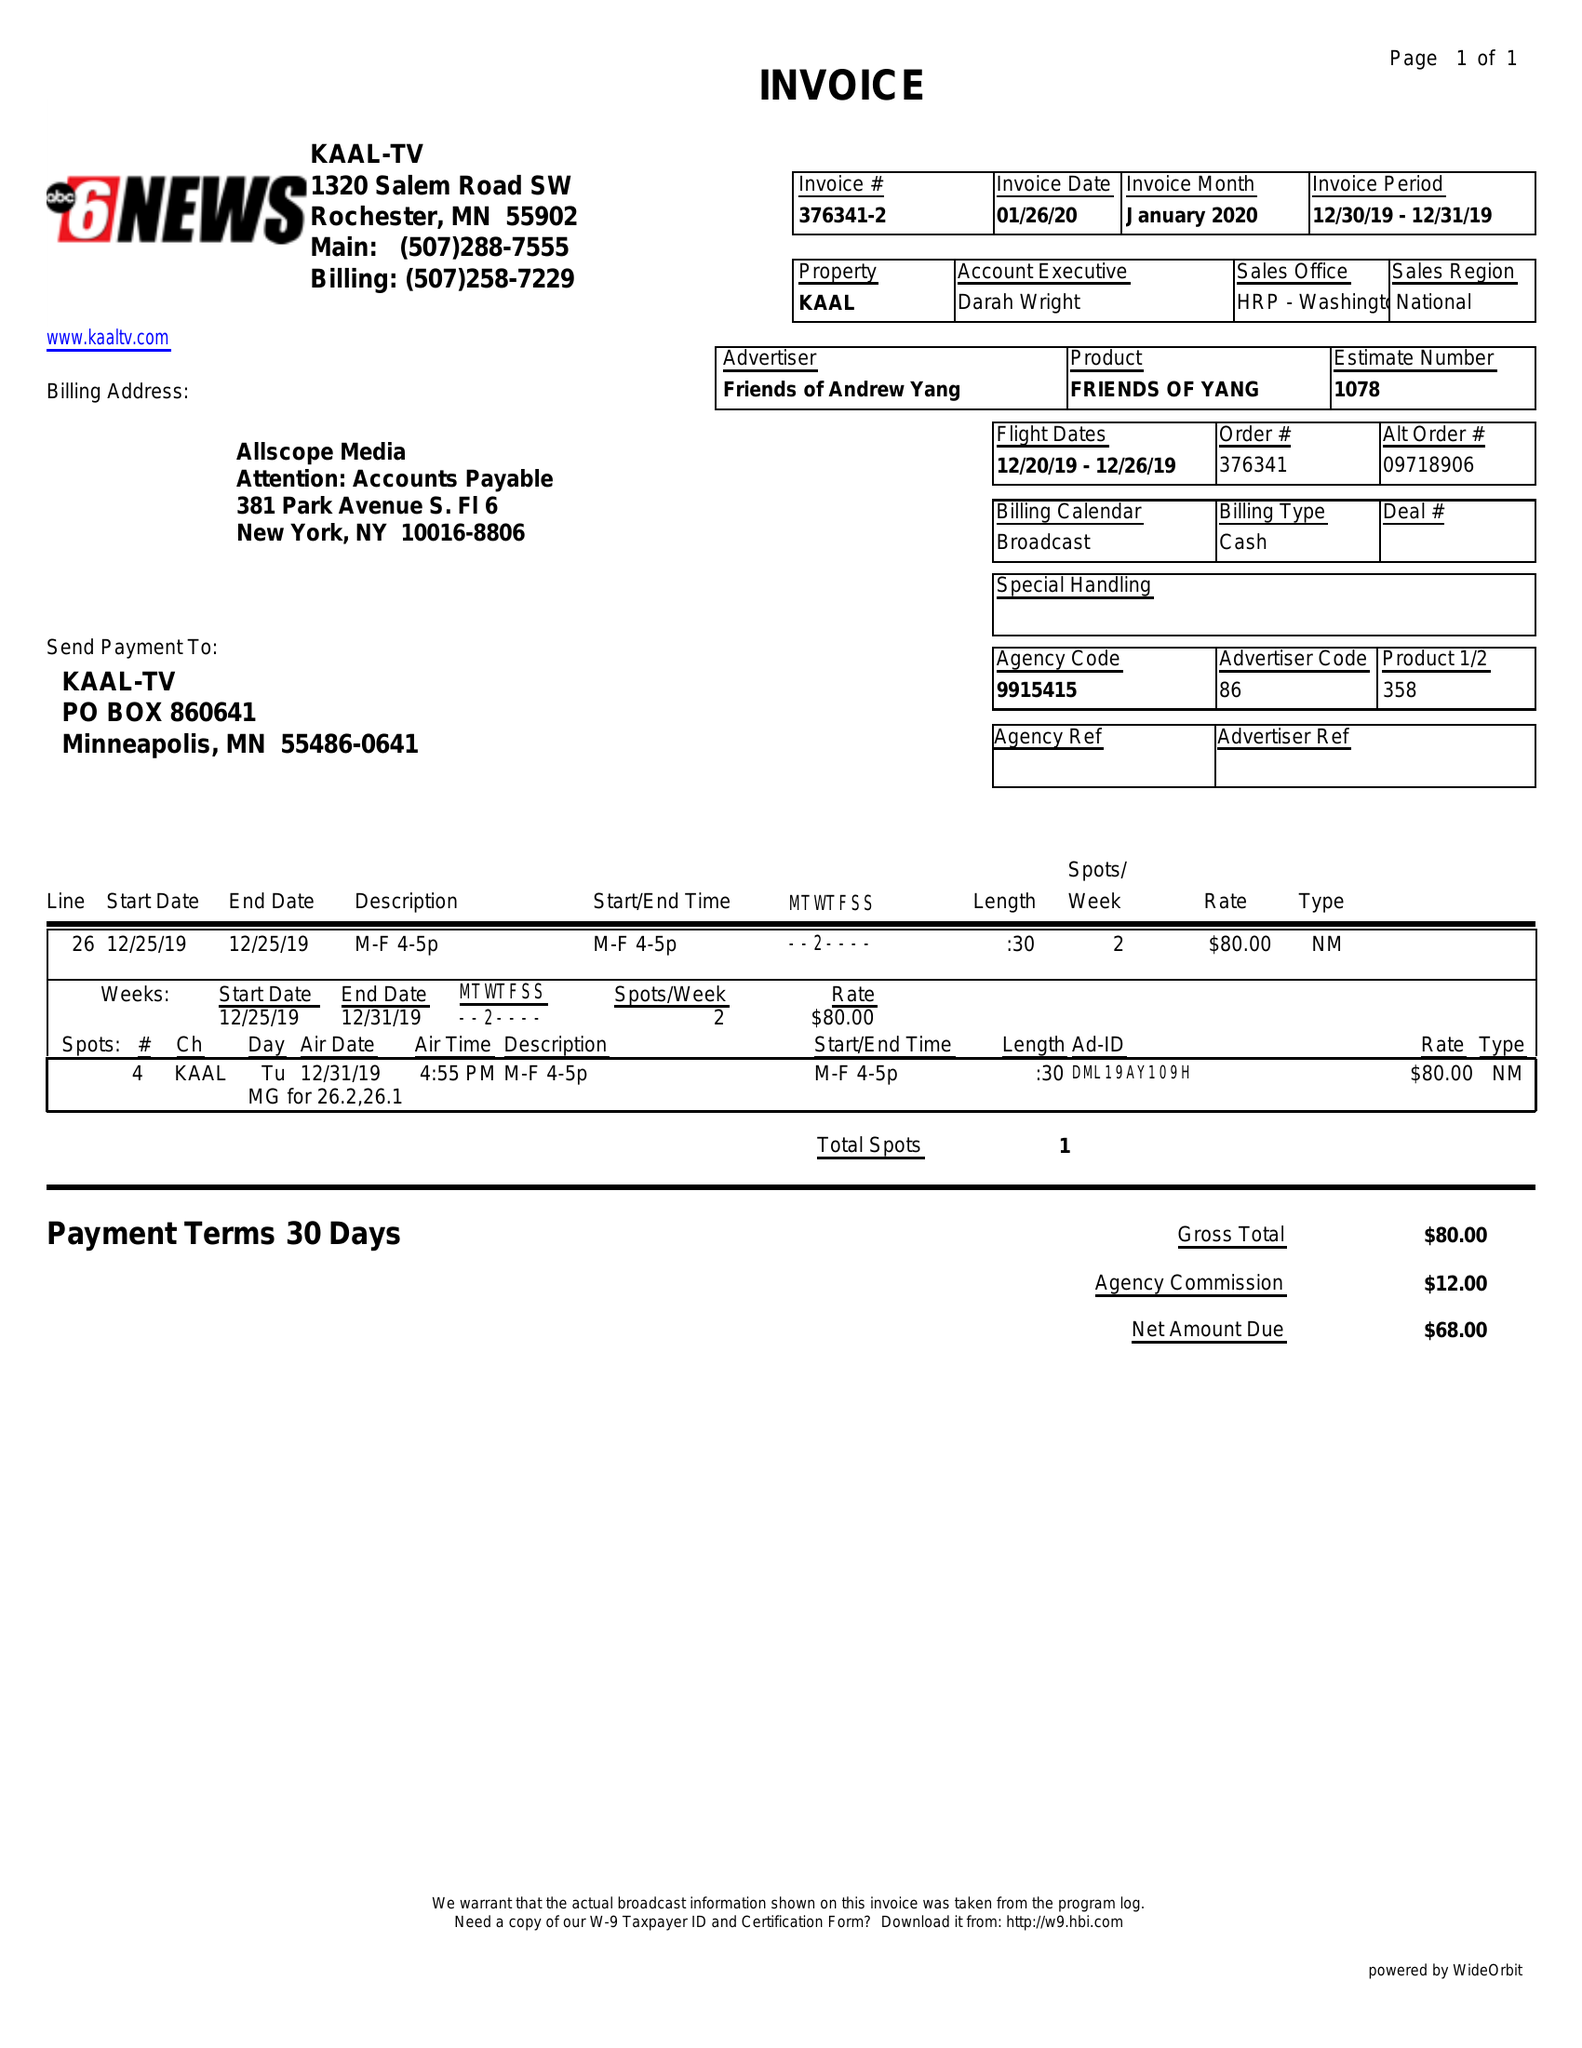What is the value for the flight_to?
Answer the question using a single word or phrase. 12/26/19 